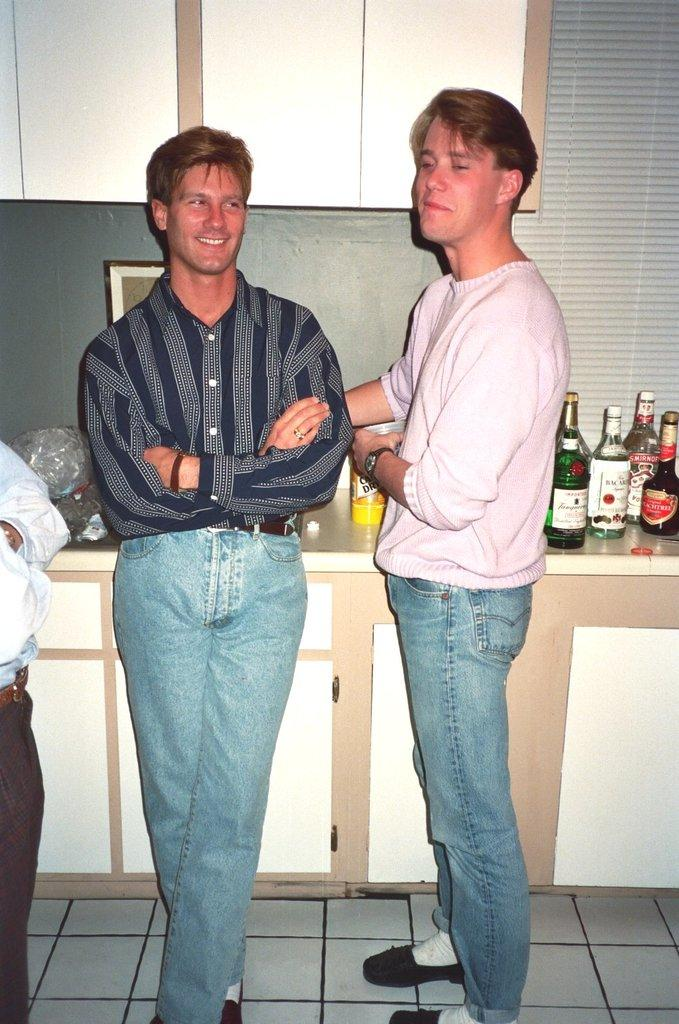How many people are in the image? There are three persons standing in the image. Where are the persons standing? The persons are standing on the floor. What can be seen in the background of the image? There are cupboards and a photo frame in the background of the image. What is placed on top of the cupboard? There is a group of bottles placed on top of the cupboard. What type of feather can be seen on the floor in the image? There is no feather present on the floor in the image. What kind of toys are being played with by the persons in the image? There is no indication of toys in the image; the persons are simply standing on the floor. 